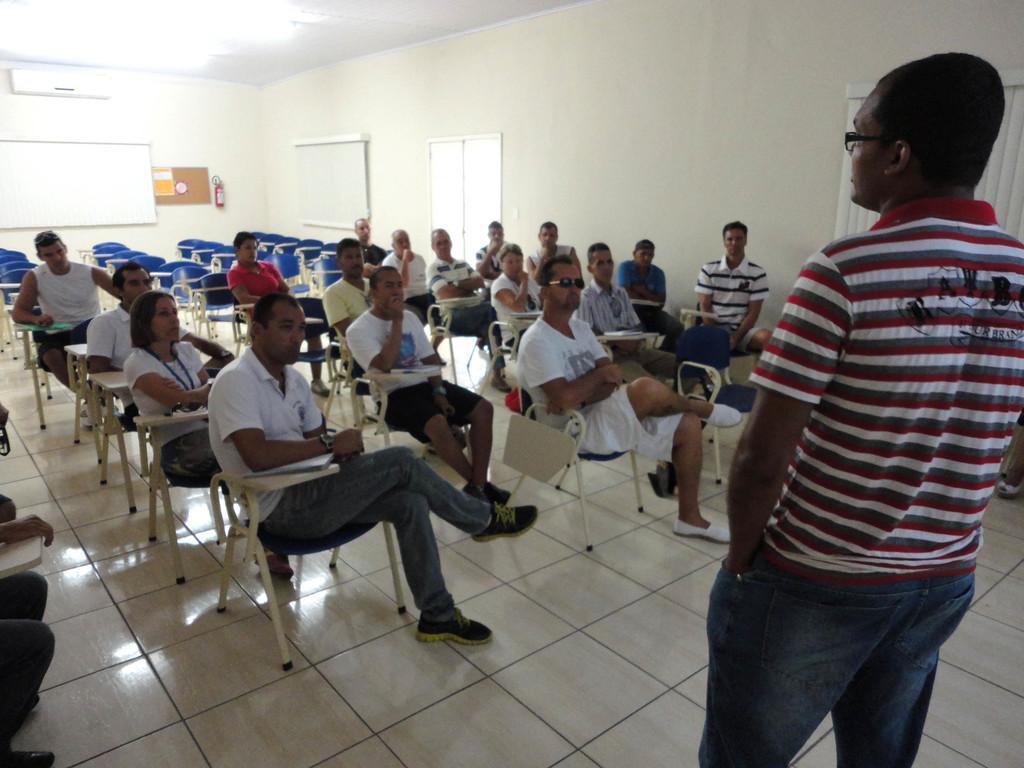In one or two sentences, can you explain what this image depicts? There are some persons sitting on the chairs as we can see in the middle of this image. There is one person standing on the right side of this image, and there is a wall in the background. 